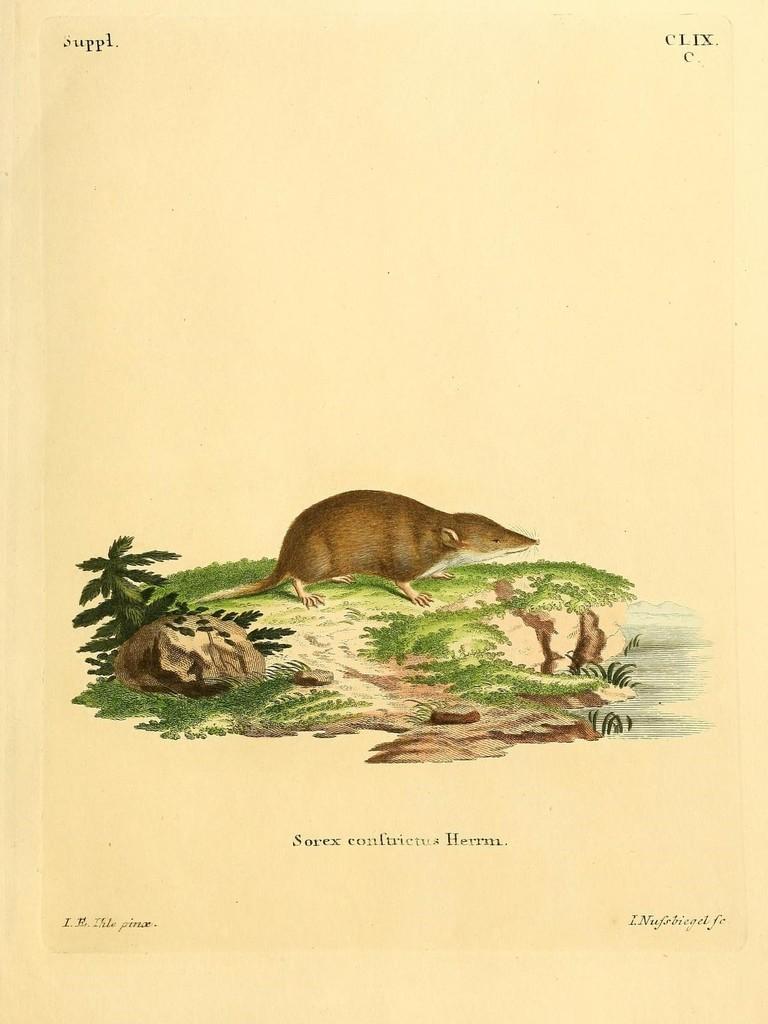In one or two sentences, can you explain what this image depicts? In this picture, we can see a poster with some images and text on it. 